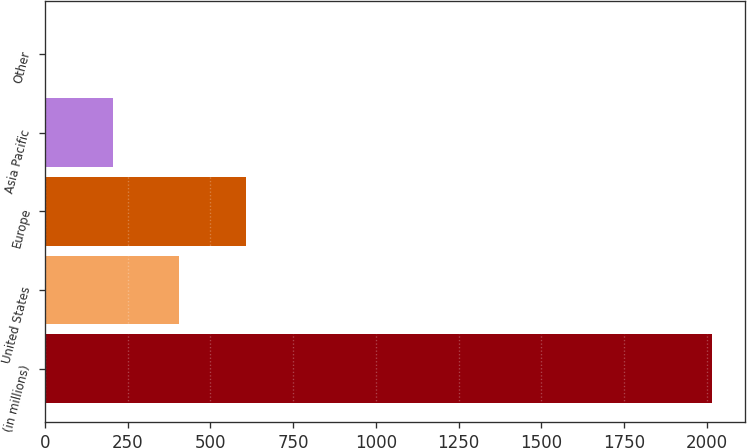Convert chart to OTSL. <chart><loc_0><loc_0><loc_500><loc_500><bar_chart><fcel>(in millions)<fcel>United States<fcel>Europe<fcel>Asia Pacific<fcel>Other<nl><fcel>2014<fcel>406.8<fcel>607.7<fcel>205.9<fcel>5<nl></chart> 